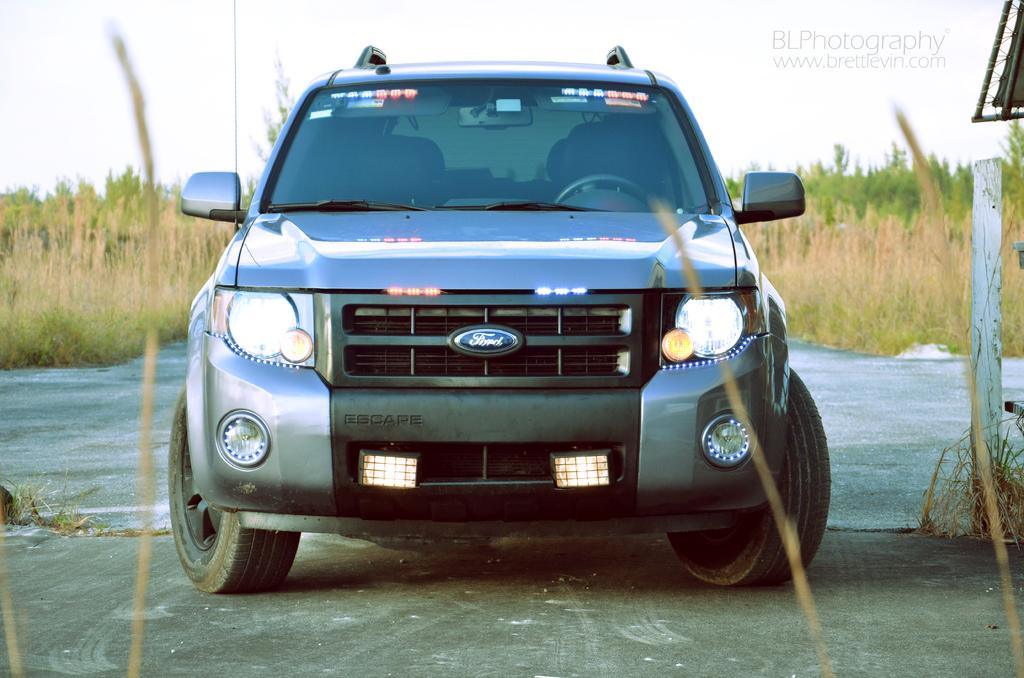What is the main subject of the image? There is a car in the image. What color is the car? The car is grey in color. What other natural elements can be seen in the image? There are plants and trees in the image. What man-made object is present in the image? There is a pole in the image. How would you describe the weather in the image? The sky is cloudy in the image. Can you hear the car's horn in the image? There is no sound present in the image, so it is not possible to hear the car's horn. What type of amusement park ride is visible in the image? There is no amusement park ride present in the image; it features a car, plants, trees, a pole, and a cloudy sky. 